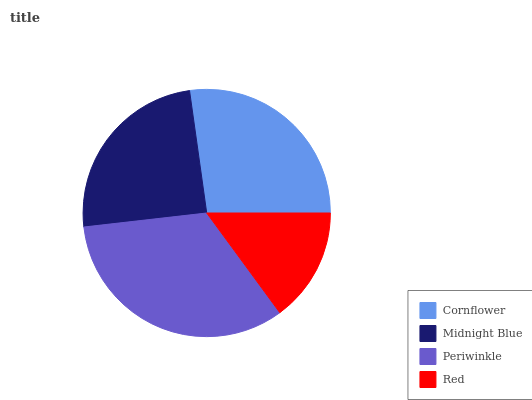Is Red the minimum?
Answer yes or no. Yes. Is Periwinkle the maximum?
Answer yes or no. Yes. Is Midnight Blue the minimum?
Answer yes or no. No. Is Midnight Blue the maximum?
Answer yes or no. No. Is Cornflower greater than Midnight Blue?
Answer yes or no. Yes. Is Midnight Blue less than Cornflower?
Answer yes or no. Yes. Is Midnight Blue greater than Cornflower?
Answer yes or no. No. Is Cornflower less than Midnight Blue?
Answer yes or no. No. Is Cornflower the high median?
Answer yes or no. Yes. Is Midnight Blue the low median?
Answer yes or no. Yes. Is Periwinkle the high median?
Answer yes or no. No. Is Periwinkle the low median?
Answer yes or no. No. 